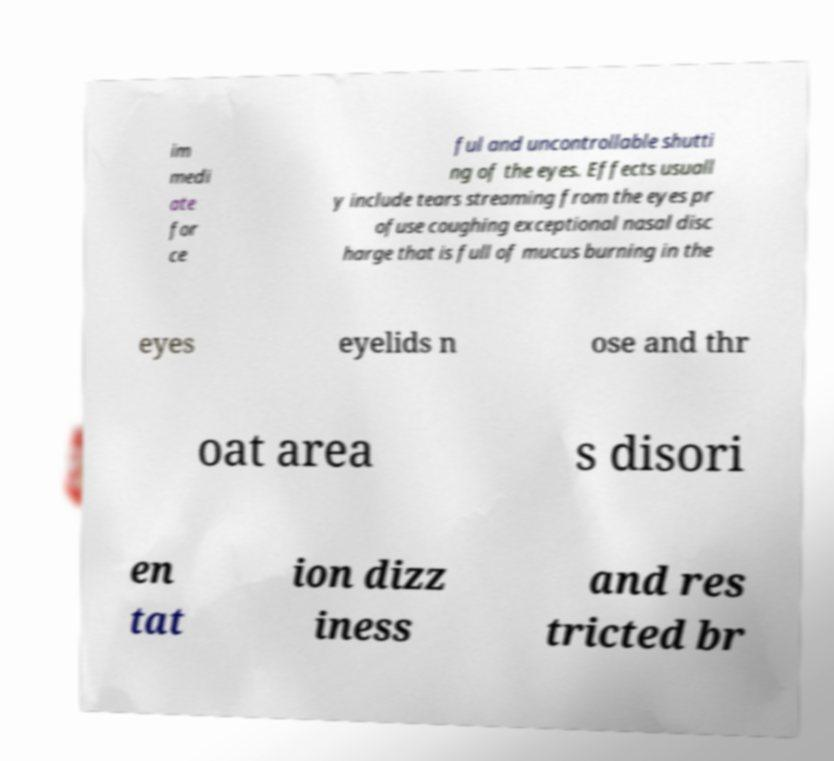Please read and relay the text visible in this image. What does it say? im medi ate for ce ful and uncontrollable shutti ng of the eyes. Effects usuall y include tears streaming from the eyes pr ofuse coughing exceptional nasal disc harge that is full of mucus burning in the eyes eyelids n ose and thr oat area s disori en tat ion dizz iness and res tricted br 